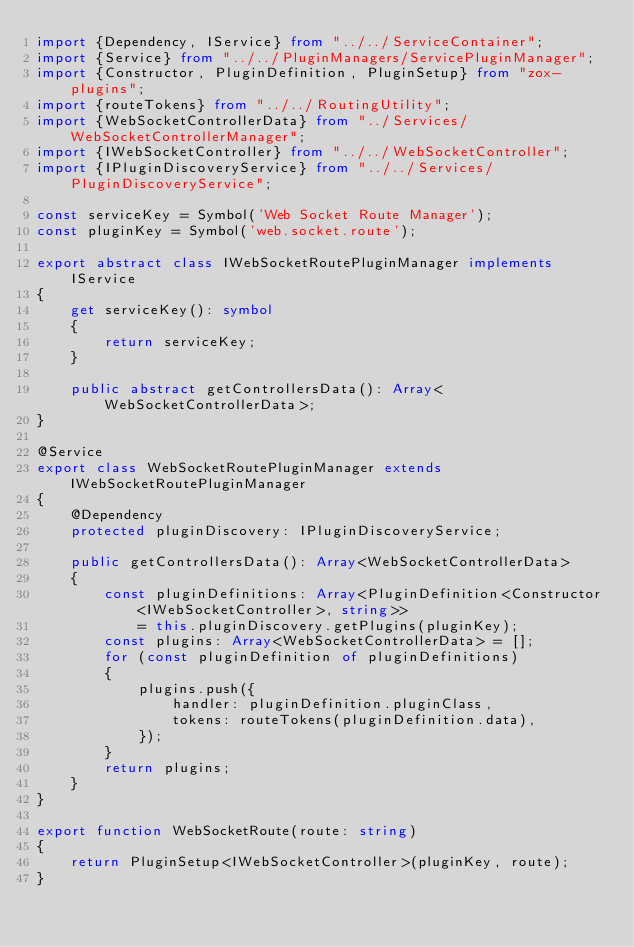Convert code to text. <code><loc_0><loc_0><loc_500><loc_500><_TypeScript_>import {Dependency, IService} from "../../ServiceContainer";
import {Service} from "../../PluginManagers/ServicePluginManager";
import {Constructor, PluginDefinition, PluginSetup} from "zox-plugins";
import {routeTokens} from "../../RoutingUtility";
import {WebSocketControllerData} from "../Services/WebSocketControllerManager";
import {IWebSocketController} from "../../WebSocketController";
import {IPluginDiscoveryService} from "../../Services/PluginDiscoveryService";

const serviceKey = Symbol('Web Socket Route Manager');
const pluginKey = Symbol('web.socket.route');

export abstract class IWebSocketRoutePluginManager implements IService
{
    get serviceKey(): symbol
    {
        return serviceKey;
    }

    public abstract getControllersData(): Array<WebSocketControllerData>;
}

@Service
export class WebSocketRoutePluginManager extends IWebSocketRoutePluginManager
{
    @Dependency
    protected pluginDiscovery: IPluginDiscoveryService;

    public getControllersData(): Array<WebSocketControllerData>
    {
        const pluginDefinitions: Array<PluginDefinition<Constructor<IWebSocketController>, string>>
            = this.pluginDiscovery.getPlugins(pluginKey);
        const plugins: Array<WebSocketControllerData> = [];
        for (const pluginDefinition of pluginDefinitions)
        {
            plugins.push({
                handler: pluginDefinition.pluginClass,
                tokens: routeTokens(pluginDefinition.data),
            });
        }
        return plugins;
    }
}

export function WebSocketRoute(route: string)
{
    return PluginSetup<IWebSocketController>(pluginKey, route);
}
</code> 